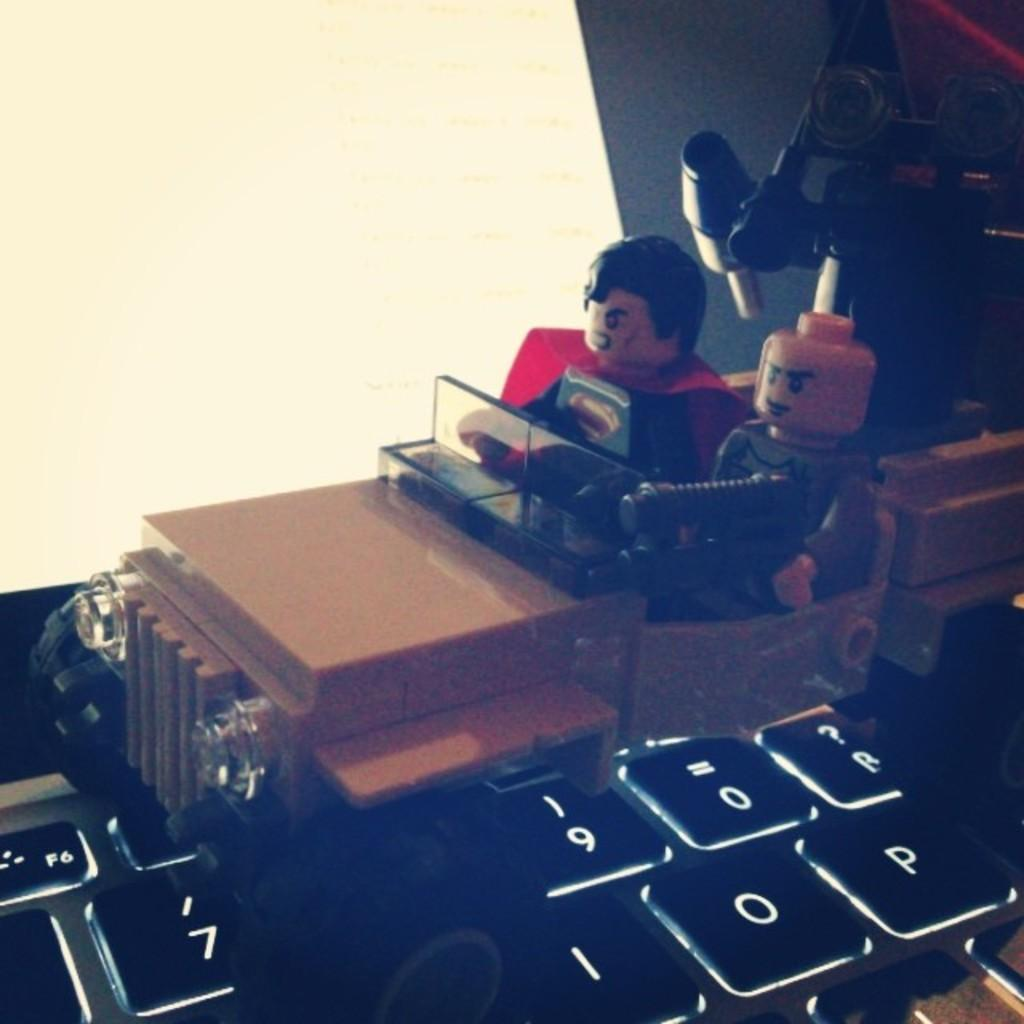What is the main object in the image? There is a keyboard in the image. What other object can be seen in the image? There is a toy car in the image. Can you describe the type of items present in the image? There are toys in the image, including a toy car. What type of soup is being served in the image? There is no soup present in the image; it features a keyboard and a toy car. Is there any mention of debt in the image? There is no mention of debt in the image; it features a keyboard and a toy car. 